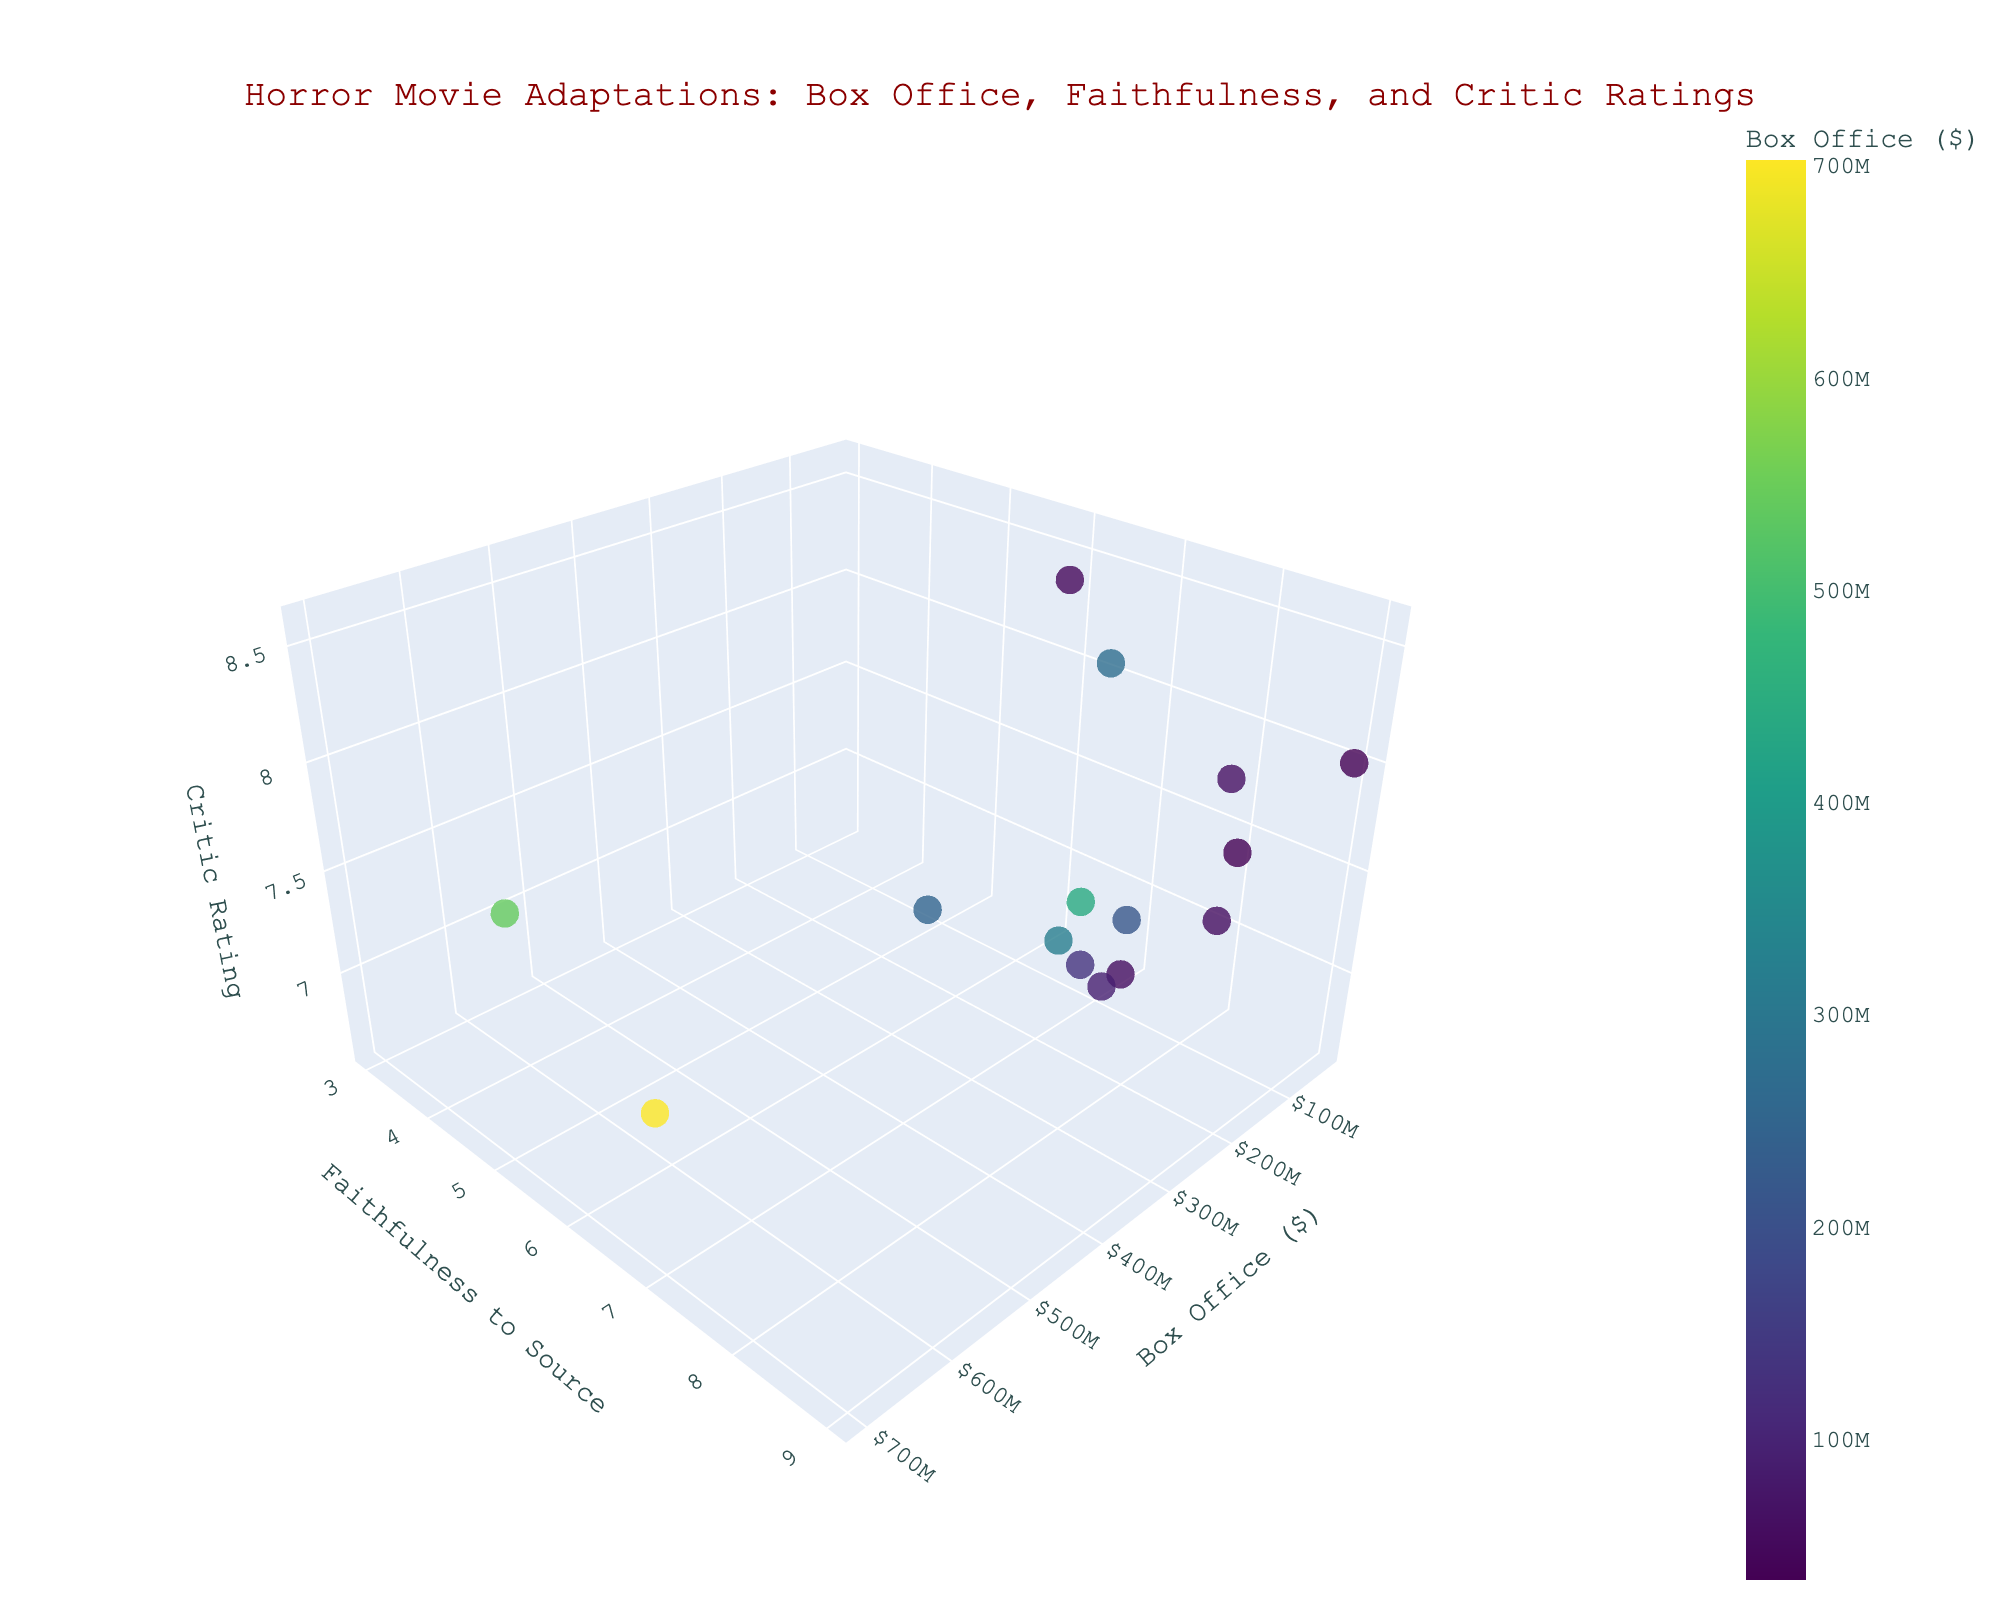What's the highest box office amount shown in the plot? The highest value on the 'Box Office ($)' axis represents the maximum box office amount. By looking at the top of the x-axis, you can see which movie has the maximum value.
Answer: $701,796,444 What's the relationship between the faithfulness to the source material and critic ratings for 'World War Z'? Locate 'World War Z' on the scatter plot. Look at its position along the 'Faithfulness to Source' axis (y-axis) and 'Critic Rating' axis (z-axis). 'World War Z' has a faithfulness of 3 and a critic rating of 7.0.
Answer: Low faithfulness and moderate rating Which movie has the closest box office amount to $100 million? Identify the points close to the $100 million mark on the x-axis and compare their actual box office values. '1408', with a box office of $132,000,000, is the closest.
Answer: '1408' Which movie has the highest faithfulness rating? Observe the uppermost data point on the 'Faithfulness to Source' axis (y-axis). The highest faithfulness rating is shared by 'The Exorcist' and 'Rosemary's Baby', both with values of 9.
Answer: 'The Exorcist' and 'Rosemary's Baby' Are there any movies with both high box office and high critic rating? Look for points that are to the far right of the x-axis (high box office) and also high on the z-axis (high critic ratings). 'It (2017)' and 'The Silence of the Lambs' fit this criterion.
Answer: 'It (2017)' and 'The Silence of the Lambs' Which movie has the lowest critic rating and how faithful is it to the source material? Locate the point at the lowest end of the z-axis (critic ratings). 'Pet Sematary (1989)' has the lowest critic rating of 6.6 and a faithfulness rating of 7.
Answer: 'Pet Sematary (1989)', 7 Which movies have a faithfulness rating equal to 8? Look for movies that are positioned at the 8 mark on the y-axis. The movies 'Carrie (1976)', 'The Silence of the Lambs', 'Misery', 'The Conjuring', 'The Mist', and 'Bram Stoker's Dracula' are all positioned here.
Answer: 'Carrie (1976)', 'The Silence of the Lambs', 'Misery', 'The Conjuring', 'The Mist', 'Bram Stoker's Dracula' Which movie had a better box office but a worse critic rating than 'Drag Me to Hell'? Identify the box office and critic rating for 'Drag Me to Hell' and compare with other movies. 'Drag Me to Hell' has a box office of $90,842,646 and a critic rating of 6.6. 'World War Z' has a better box office ($540,007,876) but a worse critic rating (7.0 is not worse).
Answer: No movie fits both criteria 